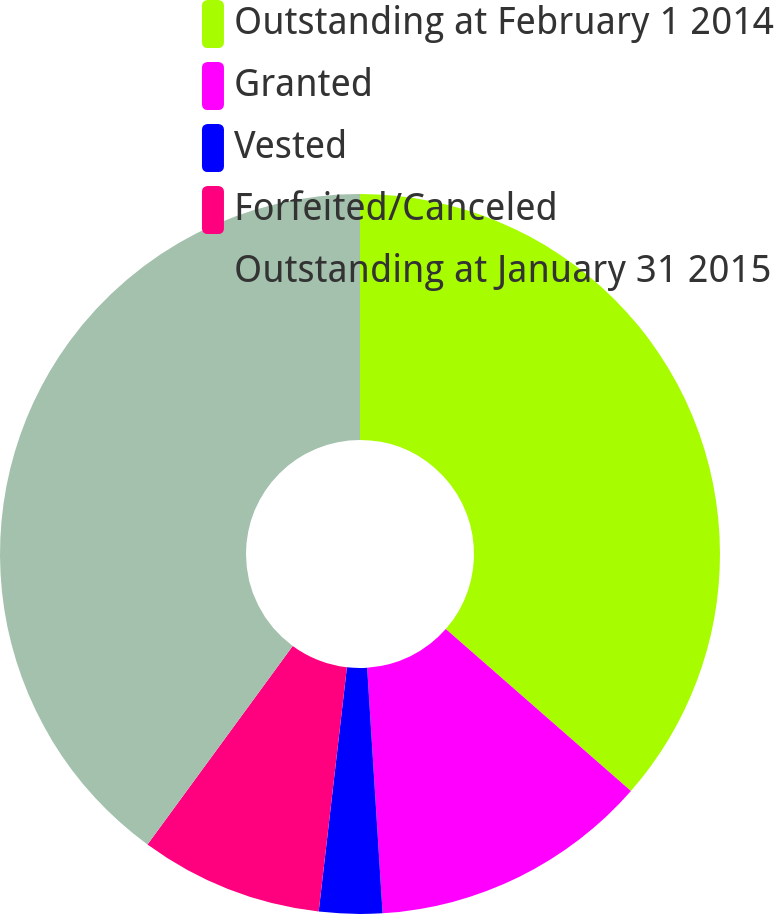Convert chart to OTSL. <chart><loc_0><loc_0><loc_500><loc_500><pie_chart><fcel>Outstanding at February 1 2014<fcel>Granted<fcel>Vested<fcel>Forfeited/Canceled<fcel>Outstanding at January 31 2015<nl><fcel>36.44%<fcel>12.56%<fcel>2.83%<fcel>8.22%<fcel>39.95%<nl></chart> 